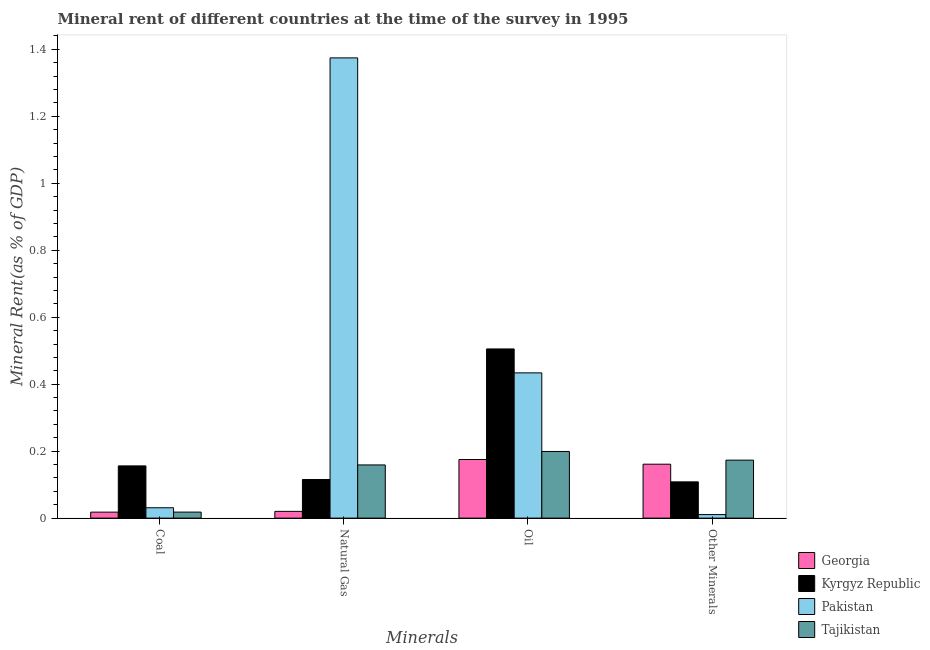Are the number of bars per tick equal to the number of legend labels?
Your answer should be very brief. Yes. How many bars are there on the 1st tick from the left?
Make the answer very short. 4. What is the label of the 1st group of bars from the left?
Your answer should be compact. Coal. What is the natural gas rent in Tajikistan?
Your answer should be very brief. 0.16. Across all countries, what is the maximum  rent of other minerals?
Offer a very short reply. 0.17. Across all countries, what is the minimum natural gas rent?
Provide a short and direct response. 0.02. In which country was the coal rent minimum?
Your answer should be very brief. Georgia. What is the total oil rent in the graph?
Offer a terse response. 1.31. What is the difference between the natural gas rent in Kyrgyz Republic and that in Tajikistan?
Keep it short and to the point. -0.04. What is the difference between the coal rent in Tajikistan and the  rent of other minerals in Kyrgyz Republic?
Offer a terse response. -0.09. What is the average natural gas rent per country?
Offer a terse response. 0.42. What is the difference between the oil rent and coal rent in Pakistan?
Give a very brief answer. 0.4. What is the ratio of the  rent of other minerals in Kyrgyz Republic to that in Tajikistan?
Give a very brief answer. 0.63. Is the  rent of other minerals in Pakistan less than that in Georgia?
Your answer should be very brief. Yes. What is the difference between the highest and the second highest  rent of other minerals?
Offer a terse response. 0.01. What is the difference between the highest and the lowest  rent of other minerals?
Your answer should be compact. 0.16. In how many countries, is the  rent of other minerals greater than the average  rent of other minerals taken over all countries?
Keep it short and to the point. 2. Is the sum of the  rent of other minerals in Georgia and Pakistan greater than the maximum coal rent across all countries?
Your answer should be compact. Yes. Is it the case that in every country, the sum of the coal rent and oil rent is greater than the sum of  rent of other minerals and natural gas rent?
Provide a succinct answer. Yes. What does the 1st bar from the left in Natural Gas represents?
Your answer should be compact. Georgia. How many countries are there in the graph?
Offer a terse response. 4. Are the values on the major ticks of Y-axis written in scientific E-notation?
Keep it short and to the point. No. Does the graph contain grids?
Ensure brevity in your answer.  No. Where does the legend appear in the graph?
Offer a terse response. Bottom right. What is the title of the graph?
Your answer should be very brief. Mineral rent of different countries at the time of the survey in 1995. Does "Sub-Saharan Africa (all income levels)" appear as one of the legend labels in the graph?
Offer a very short reply. No. What is the label or title of the X-axis?
Make the answer very short. Minerals. What is the label or title of the Y-axis?
Your answer should be very brief. Mineral Rent(as % of GDP). What is the Mineral Rent(as % of GDP) of Georgia in Coal?
Give a very brief answer. 0.02. What is the Mineral Rent(as % of GDP) in Kyrgyz Republic in Coal?
Provide a succinct answer. 0.16. What is the Mineral Rent(as % of GDP) in Pakistan in Coal?
Make the answer very short. 0.03. What is the Mineral Rent(as % of GDP) of Tajikistan in Coal?
Your answer should be compact. 0.02. What is the Mineral Rent(as % of GDP) of Georgia in Natural Gas?
Offer a very short reply. 0.02. What is the Mineral Rent(as % of GDP) of Kyrgyz Republic in Natural Gas?
Offer a very short reply. 0.12. What is the Mineral Rent(as % of GDP) of Pakistan in Natural Gas?
Keep it short and to the point. 1.37. What is the Mineral Rent(as % of GDP) of Tajikistan in Natural Gas?
Your response must be concise. 0.16. What is the Mineral Rent(as % of GDP) in Georgia in Oil?
Offer a very short reply. 0.18. What is the Mineral Rent(as % of GDP) in Kyrgyz Republic in Oil?
Your response must be concise. 0.51. What is the Mineral Rent(as % of GDP) in Pakistan in Oil?
Your answer should be very brief. 0.43. What is the Mineral Rent(as % of GDP) in Tajikistan in Oil?
Offer a terse response. 0.2. What is the Mineral Rent(as % of GDP) in Georgia in Other Minerals?
Give a very brief answer. 0.16. What is the Mineral Rent(as % of GDP) of Kyrgyz Republic in Other Minerals?
Ensure brevity in your answer.  0.11. What is the Mineral Rent(as % of GDP) in Pakistan in Other Minerals?
Provide a succinct answer. 0.01. What is the Mineral Rent(as % of GDP) in Tajikistan in Other Minerals?
Offer a very short reply. 0.17. Across all Minerals, what is the maximum Mineral Rent(as % of GDP) of Georgia?
Make the answer very short. 0.18. Across all Minerals, what is the maximum Mineral Rent(as % of GDP) in Kyrgyz Republic?
Provide a short and direct response. 0.51. Across all Minerals, what is the maximum Mineral Rent(as % of GDP) in Pakistan?
Provide a succinct answer. 1.37. Across all Minerals, what is the maximum Mineral Rent(as % of GDP) of Tajikistan?
Keep it short and to the point. 0.2. Across all Minerals, what is the minimum Mineral Rent(as % of GDP) in Georgia?
Your answer should be very brief. 0.02. Across all Minerals, what is the minimum Mineral Rent(as % of GDP) of Kyrgyz Republic?
Offer a very short reply. 0.11. Across all Minerals, what is the minimum Mineral Rent(as % of GDP) in Pakistan?
Offer a very short reply. 0.01. Across all Minerals, what is the minimum Mineral Rent(as % of GDP) of Tajikistan?
Provide a short and direct response. 0.02. What is the total Mineral Rent(as % of GDP) of Georgia in the graph?
Make the answer very short. 0.37. What is the total Mineral Rent(as % of GDP) of Kyrgyz Republic in the graph?
Offer a terse response. 0.88. What is the total Mineral Rent(as % of GDP) of Pakistan in the graph?
Provide a succinct answer. 1.85. What is the total Mineral Rent(as % of GDP) in Tajikistan in the graph?
Give a very brief answer. 0.55. What is the difference between the Mineral Rent(as % of GDP) of Georgia in Coal and that in Natural Gas?
Ensure brevity in your answer.  -0. What is the difference between the Mineral Rent(as % of GDP) of Kyrgyz Republic in Coal and that in Natural Gas?
Keep it short and to the point. 0.04. What is the difference between the Mineral Rent(as % of GDP) in Pakistan in Coal and that in Natural Gas?
Provide a succinct answer. -1.34. What is the difference between the Mineral Rent(as % of GDP) in Tajikistan in Coal and that in Natural Gas?
Make the answer very short. -0.14. What is the difference between the Mineral Rent(as % of GDP) of Georgia in Coal and that in Oil?
Provide a succinct answer. -0.16. What is the difference between the Mineral Rent(as % of GDP) of Kyrgyz Republic in Coal and that in Oil?
Offer a very short reply. -0.35. What is the difference between the Mineral Rent(as % of GDP) of Pakistan in Coal and that in Oil?
Provide a short and direct response. -0.4. What is the difference between the Mineral Rent(as % of GDP) in Tajikistan in Coal and that in Oil?
Keep it short and to the point. -0.18. What is the difference between the Mineral Rent(as % of GDP) in Georgia in Coal and that in Other Minerals?
Your answer should be compact. -0.14. What is the difference between the Mineral Rent(as % of GDP) of Kyrgyz Republic in Coal and that in Other Minerals?
Provide a short and direct response. 0.05. What is the difference between the Mineral Rent(as % of GDP) of Pakistan in Coal and that in Other Minerals?
Offer a very short reply. 0.02. What is the difference between the Mineral Rent(as % of GDP) in Tajikistan in Coal and that in Other Minerals?
Offer a very short reply. -0.16. What is the difference between the Mineral Rent(as % of GDP) in Georgia in Natural Gas and that in Oil?
Your response must be concise. -0.15. What is the difference between the Mineral Rent(as % of GDP) of Kyrgyz Republic in Natural Gas and that in Oil?
Provide a short and direct response. -0.39. What is the difference between the Mineral Rent(as % of GDP) in Pakistan in Natural Gas and that in Oil?
Offer a very short reply. 0.94. What is the difference between the Mineral Rent(as % of GDP) of Tajikistan in Natural Gas and that in Oil?
Provide a succinct answer. -0.04. What is the difference between the Mineral Rent(as % of GDP) in Georgia in Natural Gas and that in Other Minerals?
Your answer should be compact. -0.14. What is the difference between the Mineral Rent(as % of GDP) of Kyrgyz Republic in Natural Gas and that in Other Minerals?
Offer a very short reply. 0.01. What is the difference between the Mineral Rent(as % of GDP) in Pakistan in Natural Gas and that in Other Minerals?
Provide a short and direct response. 1.36. What is the difference between the Mineral Rent(as % of GDP) of Tajikistan in Natural Gas and that in Other Minerals?
Provide a succinct answer. -0.01. What is the difference between the Mineral Rent(as % of GDP) in Georgia in Oil and that in Other Minerals?
Make the answer very short. 0.01. What is the difference between the Mineral Rent(as % of GDP) of Kyrgyz Republic in Oil and that in Other Minerals?
Your answer should be very brief. 0.4. What is the difference between the Mineral Rent(as % of GDP) in Pakistan in Oil and that in Other Minerals?
Keep it short and to the point. 0.42. What is the difference between the Mineral Rent(as % of GDP) of Tajikistan in Oil and that in Other Minerals?
Give a very brief answer. 0.03. What is the difference between the Mineral Rent(as % of GDP) of Georgia in Coal and the Mineral Rent(as % of GDP) of Kyrgyz Republic in Natural Gas?
Your answer should be compact. -0.1. What is the difference between the Mineral Rent(as % of GDP) of Georgia in Coal and the Mineral Rent(as % of GDP) of Pakistan in Natural Gas?
Make the answer very short. -1.36. What is the difference between the Mineral Rent(as % of GDP) of Georgia in Coal and the Mineral Rent(as % of GDP) of Tajikistan in Natural Gas?
Make the answer very short. -0.14. What is the difference between the Mineral Rent(as % of GDP) in Kyrgyz Republic in Coal and the Mineral Rent(as % of GDP) in Pakistan in Natural Gas?
Ensure brevity in your answer.  -1.22. What is the difference between the Mineral Rent(as % of GDP) of Kyrgyz Republic in Coal and the Mineral Rent(as % of GDP) of Tajikistan in Natural Gas?
Your answer should be very brief. -0. What is the difference between the Mineral Rent(as % of GDP) of Pakistan in Coal and the Mineral Rent(as % of GDP) of Tajikistan in Natural Gas?
Give a very brief answer. -0.13. What is the difference between the Mineral Rent(as % of GDP) in Georgia in Coal and the Mineral Rent(as % of GDP) in Kyrgyz Republic in Oil?
Keep it short and to the point. -0.49. What is the difference between the Mineral Rent(as % of GDP) in Georgia in Coal and the Mineral Rent(as % of GDP) in Pakistan in Oil?
Keep it short and to the point. -0.42. What is the difference between the Mineral Rent(as % of GDP) of Georgia in Coal and the Mineral Rent(as % of GDP) of Tajikistan in Oil?
Make the answer very short. -0.18. What is the difference between the Mineral Rent(as % of GDP) in Kyrgyz Republic in Coal and the Mineral Rent(as % of GDP) in Pakistan in Oil?
Offer a very short reply. -0.28. What is the difference between the Mineral Rent(as % of GDP) of Kyrgyz Republic in Coal and the Mineral Rent(as % of GDP) of Tajikistan in Oil?
Make the answer very short. -0.04. What is the difference between the Mineral Rent(as % of GDP) in Pakistan in Coal and the Mineral Rent(as % of GDP) in Tajikistan in Oil?
Your answer should be compact. -0.17. What is the difference between the Mineral Rent(as % of GDP) in Georgia in Coal and the Mineral Rent(as % of GDP) in Kyrgyz Republic in Other Minerals?
Offer a very short reply. -0.09. What is the difference between the Mineral Rent(as % of GDP) in Georgia in Coal and the Mineral Rent(as % of GDP) in Pakistan in Other Minerals?
Provide a short and direct response. 0.01. What is the difference between the Mineral Rent(as % of GDP) in Georgia in Coal and the Mineral Rent(as % of GDP) in Tajikistan in Other Minerals?
Your answer should be very brief. -0.16. What is the difference between the Mineral Rent(as % of GDP) of Kyrgyz Republic in Coal and the Mineral Rent(as % of GDP) of Pakistan in Other Minerals?
Ensure brevity in your answer.  0.15. What is the difference between the Mineral Rent(as % of GDP) in Kyrgyz Republic in Coal and the Mineral Rent(as % of GDP) in Tajikistan in Other Minerals?
Keep it short and to the point. -0.02. What is the difference between the Mineral Rent(as % of GDP) of Pakistan in Coal and the Mineral Rent(as % of GDP) of Tajikistan in Other Minerals?
Give a very brief answer. -0.14. What is the difference between the Mineral Rent(as % of GDP) of Georgia in Natural Gas and the Mineral Rent(as % of GDP) of Kyrgyz Republic in Oil?
Offer a very short reply. -0.49. What is the difference between the Mineral Rent(as % of GDP) of Georgia in Natural Gas and the Mineral Rent(as % of GDP) of Pakistan in Oil?
Offer a terse response. -0.41. What is the difference between the Mineral Rent(as % of GDP) in Georgia in Natural Gas and the Mineral Rent(as % of GDP) in Tajikistan in Oil?
Provide a succinct answer. -0.18. What is the difference between the Mineral Rent(as % of GDP) in Kyrgyz Republic in Natural Gas and the Mineral Rent(as % of GDP) in Pakistan in Oil?
Offer a very short reply. -0.32. What is the difference between the Mineral Rent(as % of GDP) of Kyrgyz Republic in Natural Gas and the Mineral Rent(as % of GDP) of Tajikistan in Oil?
Your response must be concise. -0.08. What is the difference between the Mineral Rent(as % of GDP) of Pakistan in Natural Gas and the Mineral Rent(as % of GDP) of Tajikistan in Oil?
Ensure brevity in your answer.  1.18. What is the difference between the Mineral Rent(as % of GDP) in Georgia in Natural Gas and the Mineral Rent(as % of GDP) in Kyrgyz Republic in Other Minerals?
Keep it short and to the point. -0.09. What is the difference between the Mineral Rent(as % of GDP) of Georgia in Natural Gas and the Mineral Rent(as % of GDP) of Pakistan in Other Minerals?
Provide a succinct answer. 0.01. What is the difference between the Mineral Rent(as % of GDP) in Georgia in Natural Gas and the Mineral Rent(as % of GDP) in Tajikistan in Other Minerals?
Offer a very short reply. -0.15. What is the difference between the Mineral Rent(as % of GDP) in Kyrgyz Republic in Natural Gas and the Mineral Rent(as % of GDP) in Pakistan in Other Minerals?
Give a very brief answer. 0.1. What is the difference between the Mineral Rent(as % of GDP) in Kyrgyz Republic in Natural Gas and the Mineral Rent(as % of GDP) in Tajikistan in Other Minerals?
Keep it short and to the point. -0.06. What is the difference between the Mineral Rent(as % of GDP) of Pakistan in Natural Gas and the Mineral Rent(as % of GDP) of Tajikistan in Other Minerals?
Your answer should be very brief. 1.2. What is the difference between the Mineral Rent(as % of GDP) in Georgia in Oil and the Mineral Rent(as % of GDP) in Kyrgyz Republic in Other Minerals?
Offer a terse response. 0.07. What is the difference between the Mineral Rent(as % of GDP) in Georgia in Oil and the Mineral Rent(as % of GDP) in Pakistan in Other Minerals?
Your answer should be very brief. 0.16. What is the difference between the Mineral Rent(as % of GDP) of Georgia in Oil and the Mineral Rent(as % of GDP) of Tajikistan in Other Minerals?
Give a very brief answer. 0. What is the difference between the Mineral Rent(as % of GDP) of Kyrgyz Republic in Oil and the Mineral Rent(as % of GDP) of Pakistan in Other Minerals?
Offer a very short reply. 0.49. What is the difference between the Mineral Rent(as % of GDP) of Kyrgyz Republic in Oil and the Mineral Rent(as % of GDP) of Tajikistan in Other Minerals?
Make the answer very short. 0.33. What is the difference between the Mineral Rent(as % of GDP) in Pakistan in Oil and the Mineral Rent(as % of GDP) in Tajikistan in Other Minerals?
Ensure brevity in your answer.  0.26. What is the average Mineral Rent(as % of GDP) of Georgia per Minerals?
Your response must be concise. 0.09. What is the average Mineral Rent(as % of GDP) of Kyrgyz Republic per Minerals?
Your answer should be very brief. 0.22. What is the average Mineral Rent(as % of GDP) of Pakistan per Minerals?
Provide a succinct answer. 0.46. What is the average Mineral Rent(as % of GDP) in Tajikistan per Minerals?
Your answer should be compact. 0.14. What is the difference between the Mineral Rent(as % of GDP) of Georgia and Mineral Rent(as % of GDP) of Kyrgyz Republic in Coal?
Keep it short and to the point. -0.14. What is the difference between the Mineral Rent(as % of GDP) of Georgia and Mineral Rent(as % of GDP) of Pakistan in Coal?
Provide a short and direct response. -0.01. What is the difference between the Mineral Rent(as % of GDP) in Georgia and Mineral Rent(as % of GDP) in Tajikistan in Coal?
Ensure brevity in your answer.  -0. What is the difference between the Mineral Rent(as % of GDP) of Kyrgyz Republic and Mineral Rent(as % of GDP) of Pakistan in Coal?
Your response must be concise. 0.12. What is the difference between the Mineral Rent(as % of GDP) in Kyrgyz Republic and Mineral Rent(as % of GDP) in Tajikistan in Coal?
Make the answer very short. 0.14. What is the difference between the Mineral Rent(as % of GDP) in Pakistan and Mineral Rent(as % of GDP) in Tajikistan in Coal?
Make the answer very short. 0.01. What is the difference between the Mineral Rent(as % of GDP) of Georgia and Mineral Rent(as % of GDP) of Kyrgyz Republic in Natural Gas?
Give a very brief answer. -0.1. What is the difference between the Mineral Rent(as % of GDP) of Georgia and Mineral Rent(as % of GDP) of Pakistan in Natural Gas?
Ensure brevity in your answer.  -1.35. What is the difference between the Mineral Rent(as % of GDP) in Georgia and Mineral Rent(as % of GDP) in Tajikistan in Natural Gas?
Offer a very short reply. -0.14. What is the difference between the Mineral Rent(as % of GDP) in Kyrgyz Republic and Mineral Rent(as % of GDP) in Pakistan in Natural Gas?
Offer a terse response. -1.26. What is the difference between the Mineral Rent(as % of GDP) of Kyrgyz Republic and Mineral Rent(as % of GDP) of Tajikistan in Natural Gas?
Keep it short and to the point. -0.04. What is the difference between the Mineral Rent(as % of GDP) in Pakistan and Mineral Rent(as % of GDP) in Tajikistan in Natural Gas?
Give a very brief answer. 1.22. What is the difference between the Mineral Rent(as % of GDP) in Georgia and Mineral Rent(as % of GDP) in Kyrgyz Republic in Oil?
Your response must be concise. -0.33. What is the difference between the Mineral Rent(as % of GDP) of Georgia and Mineral Rent(as % of GDP) of Pakistan in Oil?
Your answer should be compact. -0.26. What is the difference between the Mineral Rent(as % of GDP) in Georgia and Mineral Rent(as % of GDP) in Tajikistan in Oil?
Ensure brevity in your answer.  -0.02. What is the difference between the Mineral Rent(as % of GDP) in Kyrgyz Republic and Mineral Rent(as % of GDP) in Pakistan in Oil?
Your answer should be very brief. 0.07. What is the difference between the Mineral Rent(as % of GDP) in Kyrgyz Republic and Mineral Rent(as % of GDP) in Tajikistan in Oil?
Keep it short and to the point. 0.31. What is the difference between the Mineral Rent(as % of GDP) of Pakistan and Mineral Rent(as % of GDP) of Tajikistan in Oil?
Your answer should be compact. 0.23. What is the difference between the Mineral Rent(as % of GDP) in Georgia and Mineral Rent(as % of GDP) in Kyrgyz Republic in Other Minerals?
Your response must be concise. 0.05. What is the difference between the Mineral Rent(as % of GDP) of Georgia and Mineral Rent(as % of GDP) of Pakistan in Other Minerals?
Your response must be concise. 0.15. What is the difference between the Mineral Rent(as % of GDP) in Georgia and Mineral Rent(as % of GDP) in Tajikistan in Other Minerals?
Provide a short and direct response. -0.01. What is the difference between the Mineral Rent(as % of GDP) of Kyrgyz Republic and Mineral Rent(as % of GDP) of Pakistan in Other Minerals?
Offer a terse response. 0.1. What is the difference between the Mineral Rent(as % of GDP) in Kyrgyz Republic and Mineral Rent(as % of GDP) in Tajikistan in Other Minerals?
Keep it short and to the point. -0.06. What is the difference between the Mineral Rent(as % of GDP) in Pakistan and Mineral Rent(as % of GDP) in Tajikistan in Other Minerals?
Offer a terse response. -0.16. What is the ratio of the Mineral Rent(as % of GDP) of Georgia in Coal to that in Natural Gas?
Offer a very short reply. 0.89. What is the ratio of the Mineral Rent(as % of GDP) in Kyrgyz Republic in Coal to that in Natural Gas?
Give a very brief answer. 1.35. What is the ratio of the Mineral Rent(as % of GDP) of Pakistan in Coal to that in Natural Gas?
Keep it short and to the point. 0.02. What is the ratio of the Mineral Rent(as % of GDP) in Tajikistan in Coal to that in Natural Gas?
Your answer should be very brief. 0.11. What is the ratio of the Mineral Rent(as % of GDP) in Georgia in Coal to that in Oil?
Your response must be concise. 0.1. What is the ratio of the Mineral Rent(as % of GDP) of Kyrgyz Republic in Coal to that in Oil?
Give a very brief answer. 0.31. What is the ratio of the Mineral Rent(as % of GDP) of Pakistan in Coal to that in Oil?
Make the answer very short. 0.07. What is the ratio of the Mineral Rent(as % of GDP) of Tajikistan in Coal to that in Oil?
Ensure brevity in your answer.  0.09. What is the ratio of the Mineral Rent(as % of GDP) of Georgia in Coal to that in Other Minerals?
Offer a very short reply. 0.11. What is the ratio of the Mineral Rent(as % of GDP) of Kyrgyz Republic in Coal to that in Other Minerals?
Provide a succinct answer. 1.44. What is the ratio of the Mineral Rent(as % of GDP) in Pakistan in Coal to that in Other Minerals?
Your answer should be compact. 2.93. What is the ratio of the Mineral Rent(as % of GDP) in Tajikistan in Coal to that in Other Minerals?
Provide a short and direct response. 0.1. What is the ratio of the Mineral Rent(as % of GDP) of Georgia in Natural Gas to that in Oil?
Provide a succinct answer. 0.12. What is the ratio of the Mineral Rent(as % of GDP) in Kyrgyz Republic in Natural Gas to that in Oil?
Keep it short and to the point. 0.23. What is the ratio of the Mineral Rent(as % of GDP) in Pakistan in Natural Gas to that in Oil?
Your answer should be compact. 3.17. What is the ratio of the Mineral Rent(as % of GDP) of Tajikistan in Natural Gas to that in Oil?
Provide a succinct answer. 0.8. What is the ratio of the Mineral Rent(as % of GDP) in Georgia in Natural Gas to that in Other Minerals?
Give a very brief answer. 0.13. What is the ratio of the Mineral Rent(as % of GDP) of Kyrgyz Republic in Natural Gas to that in Other Minerals?
Provide a short and direct response. 1.06. What is the ratio of the Mineral Rent(as % of GDP) in Pakistan in Natural Gas to that in Other Minerals?
Ensure brevity in your answer.  130.33. What is the ratio of the Mineral Rent(as % of GDP) of Tajikistan in Natural Gas to that in Other Minerals?
Offer a very short reply. 0.92. What is the ratio of the Mineral Rent(as % of GDP) in Georgia in Oil to that in Other Minerals?
Your answer should be very brief. 1.09. What is the ratio of the Mineral Rent(as % of GDP) of Kyrgyz Republic in Oil to that in Other Minerals?
Your answer should be compact. 4.67. What is the ratio of the Mineral Rent(as % of GDP) of Pakistan in Oil to that in Other Minerals?
Make the answer very short. 41.13. What is the ratio of the Mineral Rent(as % of GDP) in Tajikistan in Oil to that in Other Minerals?
Ensure brevity in your answer.  1.15. What is the difference between the highest and the second highest Mineral Rent(as % of GDP) of Georgia?
Your answer should be compact. 0.01. What is the difference between the highest and the second highest Mineral Rent(as % of GDP) in Kyrgyz Republic?
Your answer should be very brief. 0.35. What is the difference between the highest and the second highest Mineral Rent(as % of GDP) of Pakistan?
Your answer should be compact. 0.94. What is the difference between the highest and the second highest Mineral Rent(as % of GDP) in Tajikistan?
Offer a terse response. 0.03. What is the difference between the highest and the lowest Mineral Rent(as % of GDP) in Georgia?
Provide a short and direct response. 0.16. What is the difference between the highest and the lowest Mineral Rent(as % of GDP) in Kyrgyz Republic?
Provide a succinct answer. 0.4. What is the difference between the highest and the lowest Mineral Rent(as % of GDP) in Pakistan?
Provide a succinct answer. 1.36. What is the difference between the highest and the lowest Mineral Rent(as % of GDP) of Tajikistan?
Your answer should be compact. 0.18. 